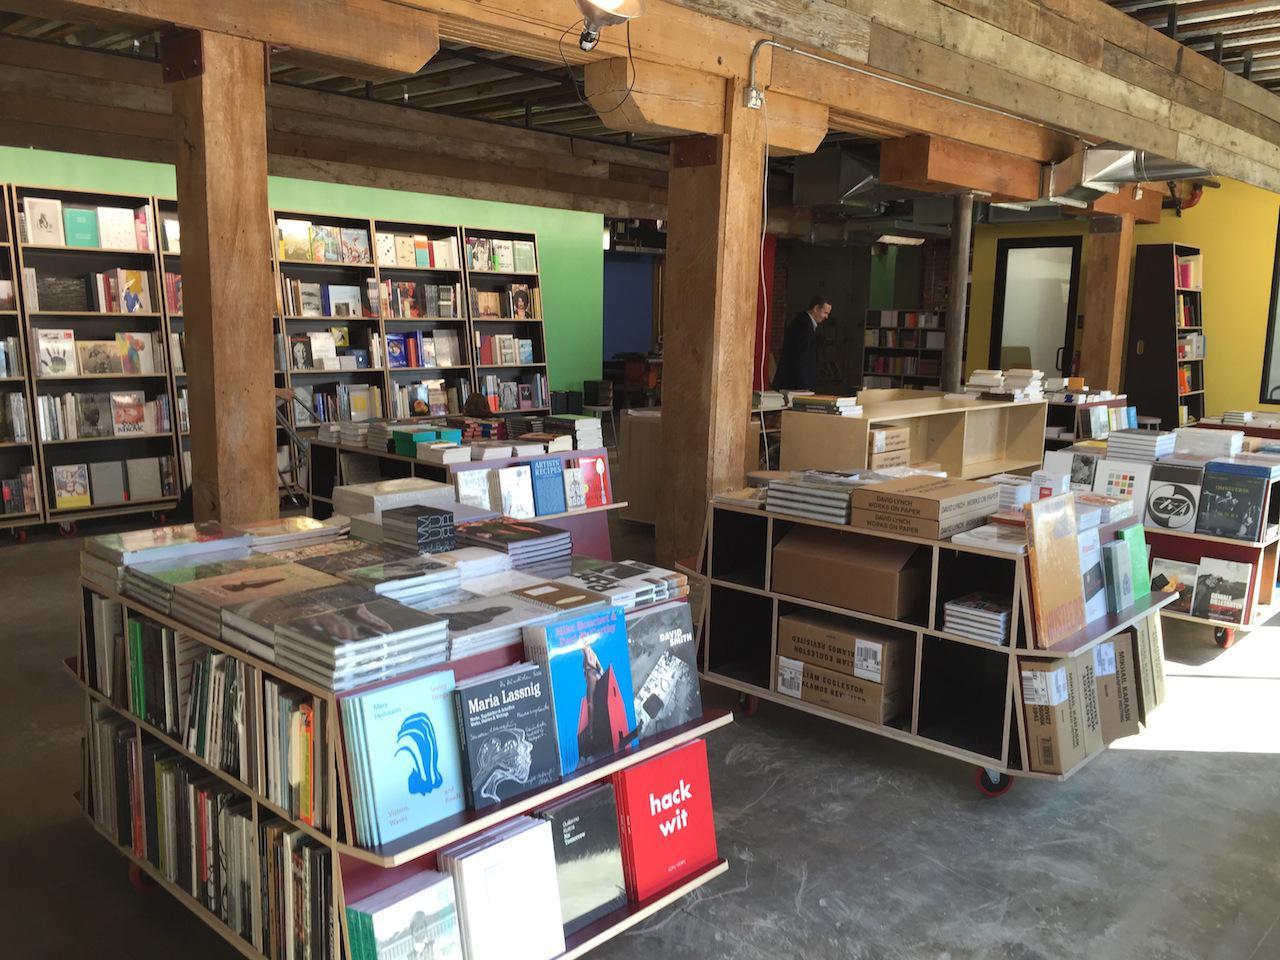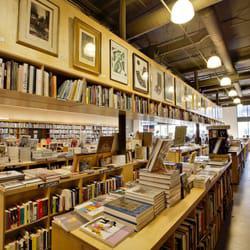The first image is the image on the left, the second image is the image on the right. Analyze the images presented: Is the assertion "The right image shows a bookstore interior with T-shaped wooden support beams in front of a green wall and behind freestanding displays of books." valid? Answer yes or no. No. The first image is the image on the left, the second image is the image on the right. Analyze the images presented: Is the assertion "There are banks of fluorescent lights visible in at least one of the images." valid? Answer yes or no. No. 